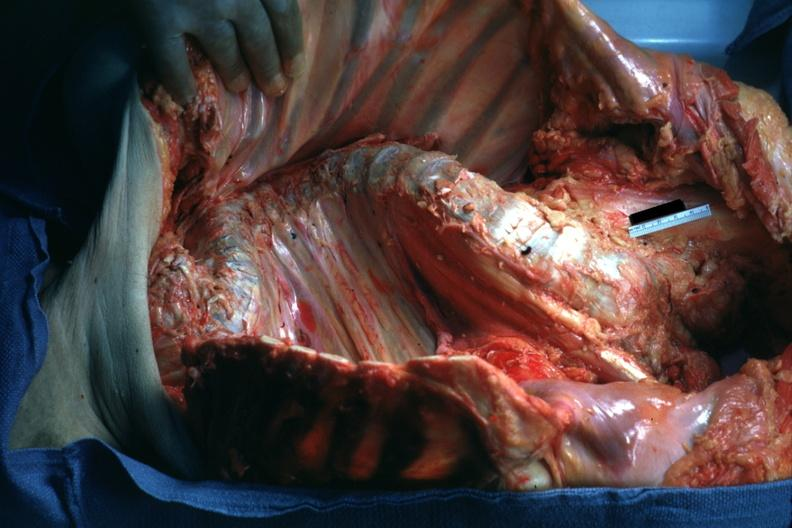does peritoneal fluid show opened body with organs?
Answer the question using a single word or phrase. No 